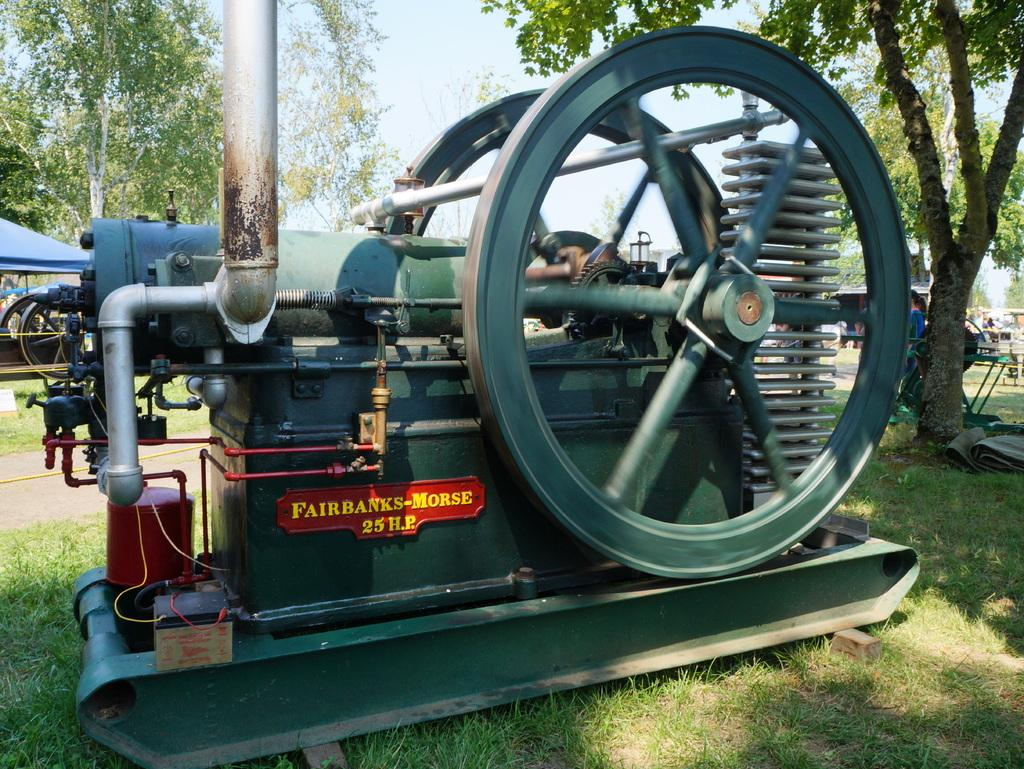What is located on the grassy land in the image? There is a machine present on the grassy land. What can be seen behind the machine? Trees are visible behind the machine. What is visible in the background of the image? The sky is visible in the image. What type of structure is on the left side of the image? There is a blue color shelter on the left side of the image. What type of yoke is being used to control the mist in the image? There is no yoke or mist present in the image. What rule is being enforced by the machine in the image? The image does not depict any rules or enforcement; it simply shows a machine on grassy land with trees and a blue color shelter in the background. 